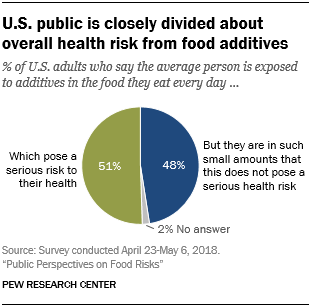Identify some key points in this picture. In a set of seven segments with a total length of 30, the ratio of the second largest segment to the smallest segment is 24:8. The color of the largest segment is green. 